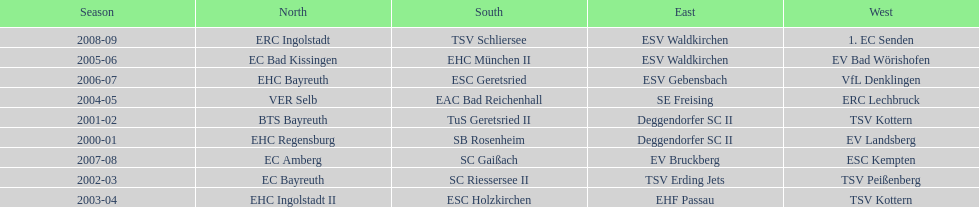What is the number of seasons covered in the table? 9. 